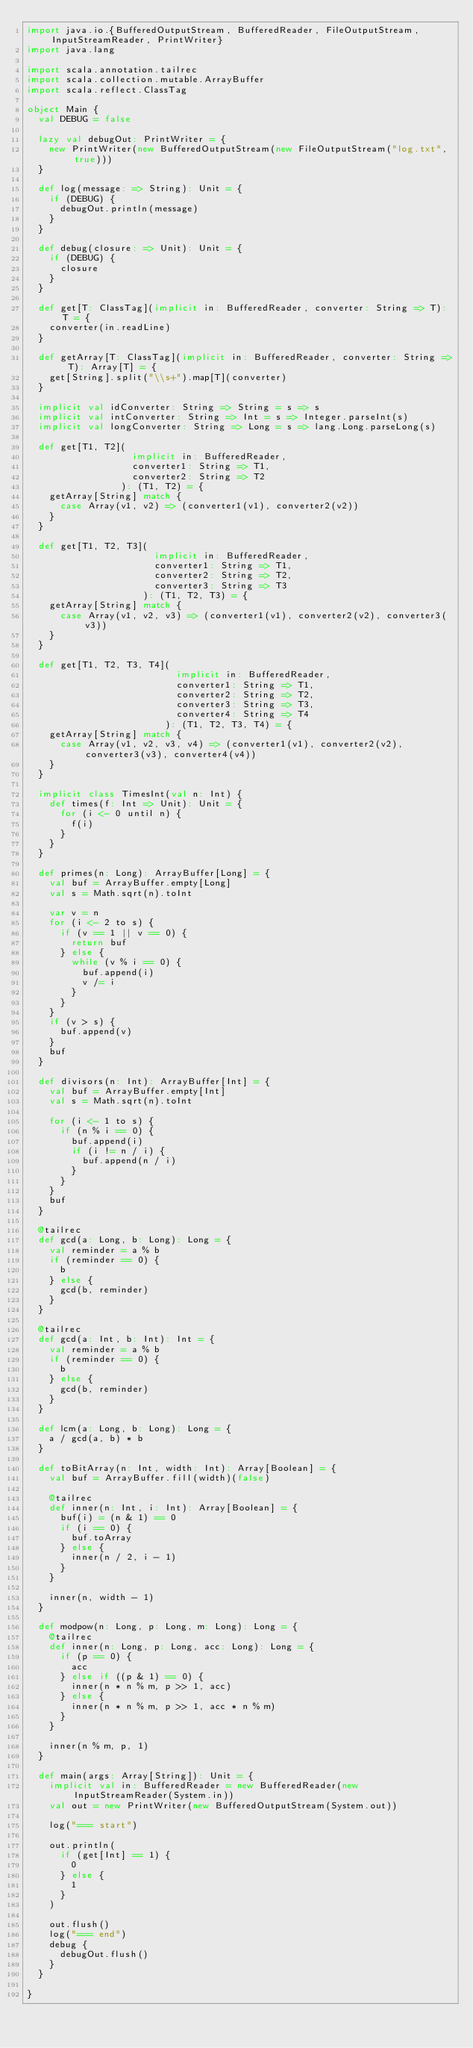Convert code to text. <code><loc_0><loc_0><loc_500><loc_500><_Scala_>import java.io.{BufferedOutputStream, BufferedReader, FileOutputStream, InputStreamReader, PrintWriter}
import java.lang

import scala.annotation.tailrec
import scala.collection.mutable.ArrayBuffer
import scala.reflect.ClassTag

object Main {
  val DEBUG = false

  lazy val debugOut: PrintWriter = {
    new PrintWriter(new BufferedOutputStream(new FileOutputStream("log.txt", true)))
  }

  def log(message: => String): Unit = {
    if (DEBUG) {
      debugOut.println(message)
    }
  }

  def debug(closure: => Unit): Unit = {
    if (DEBUG) {
      closure
    }
  }

  def get[T: ClassTag](implicit in: BufferedReader, converter: String => T): T = {
    converter(in.readLine)
  }

  def getArray[T: ClassTag](implicit in: BufferedReader, converter: String => T): Array[T] = {
    get[String].split("\\s+").map[T](converter)
  }

  implicit val idConverter: String => String = s => s
  implicit val intConverter: String => Int = s => Integer.parseInt(s)
  implicit val longConverter: String => Long = s => lang.Long.parseLong(s)

  def get[T1, T2](
                   implicit in: BufferedReader,
                   converter1: String => T1,
                   converter2: String => T2
                 ): (T1, T2) = {
    getArray[String] match {
      case Array(v1, v2) => (converter1(v1), converter2(v2))
    }
  }

  def get[T1, T2, T3](
                       implicit in: BufferedReader,
                       converter1: String => T1,
                       converter2: String => T2,
                       converter3: String => T3
                     ): (T1, T2, T3) = {
    getArray[String] match {
      case Array(v1, v2, v3) => (converter1(v1), converter2(v2), converter3(v3))
    }
  }

  def get[T1, T2, T3, T4](
                           implicit in: BufferedReader,
                           converter1: String => T1,
                           converter2: String => T2,
                           converter3: String => T3,
                           converter4: String => T4
                         ): (T1, T2, T3, T4) = {
    getArray[String] match {
      case Array(v1, v2, v3, v4) => (converter1(v1), converter2(v2), converter3(v3), converter4(v4))
    }
  }

  implicit class TimesInt(val n: Int) {
    def times(f: Int => Unit): Unit = {
      for (i <- 0 until n) {
        f(i)
      }
    }
  }

  def primes(n: Long): ArrayBuffer[Long] = {
    val buf = ArrayBuffer.empty[Long]
    val s = Math.sqrt(n).toInt

    var v = n
    for (i <- 2 to s) {
      if (v == 1 || v == 0) {
        return buf
      } else {
        while (v % i == 0) {
          buf.append(i)
          v /= i
        }
      }
    }
    if (v > s) {
      buf.append(v)
    }
    buf
  }

  def divisors(n: Int): ArrayBuffer[Int] = {
    val buf = ArrayBuffer.empty[Int]
    val s = Math.sqrt(n).toInt

    for (i <- 1 to s) {
      if (n % i == 0) {
        buf.append(i)
        if (i != n / i) {
          buf.append(n / i)
        }
      }
    }
    buf
  }

  @tailrec
  def gcd(a: Long, b: Long): Long = {
    val reminder = a % b
    if (reminder == 0) {
      b
    } else {
      gcd(b, reminder)
    }
  }

  @tailrec
  def gcd(a: Int, b: Int): Int = {
    val reminder = a % b
    if (reminder == 0) {
      b
    } else {
      gcd(b, reminder)
    }
  }

  def lcm(a: Long, b: Long): Long = {
    a / gcd(a, b) * b
  }

  def toBitArray(n: Int, width: Int): Array[Boolean] = {
    val buf = ArrayBuffer.fill(width)(false)

    @tailrec
    def inner(n: Int, i: Int): Array[Boolean] = {
      buf(i) = (n & 1) == 0
      if (i == 0) {
        buf.toArray
      } else {
        inner(n / 2, i - 1)
      }
    }

    inner(n, width - 1)
  }

  def modpow(n: Long, p: Long, m: Long): Long = {
    @tailrec
    def inner(n: Long, p: Long, acc: Long): Long = {
      if (p == 0) {
        acc
      } else if ((p & 1) == 0) {
        inner(n * n % m, p >> 1, acc)
      } else {
        inner(n * n % m, p >> 1, acc * n % m)
      }
    }

    inner(n % m, p, 1)
  }

  def main(args: Array[String]): Unit = {
    implicit val in: BufferedReader = new BufferedReader(new InputStreamReader(System.in))
    val out = new PrintWriter(new BufferedOutputStream(System.out))

    log("=== start")

    out.println(
      if (get[Int] == 1) {
        0
      } else {
        1
      }
    )
    
    out.flush()
    log("=== end")
    debug {
      debugOut.flush()
    }
  }

}</code> 